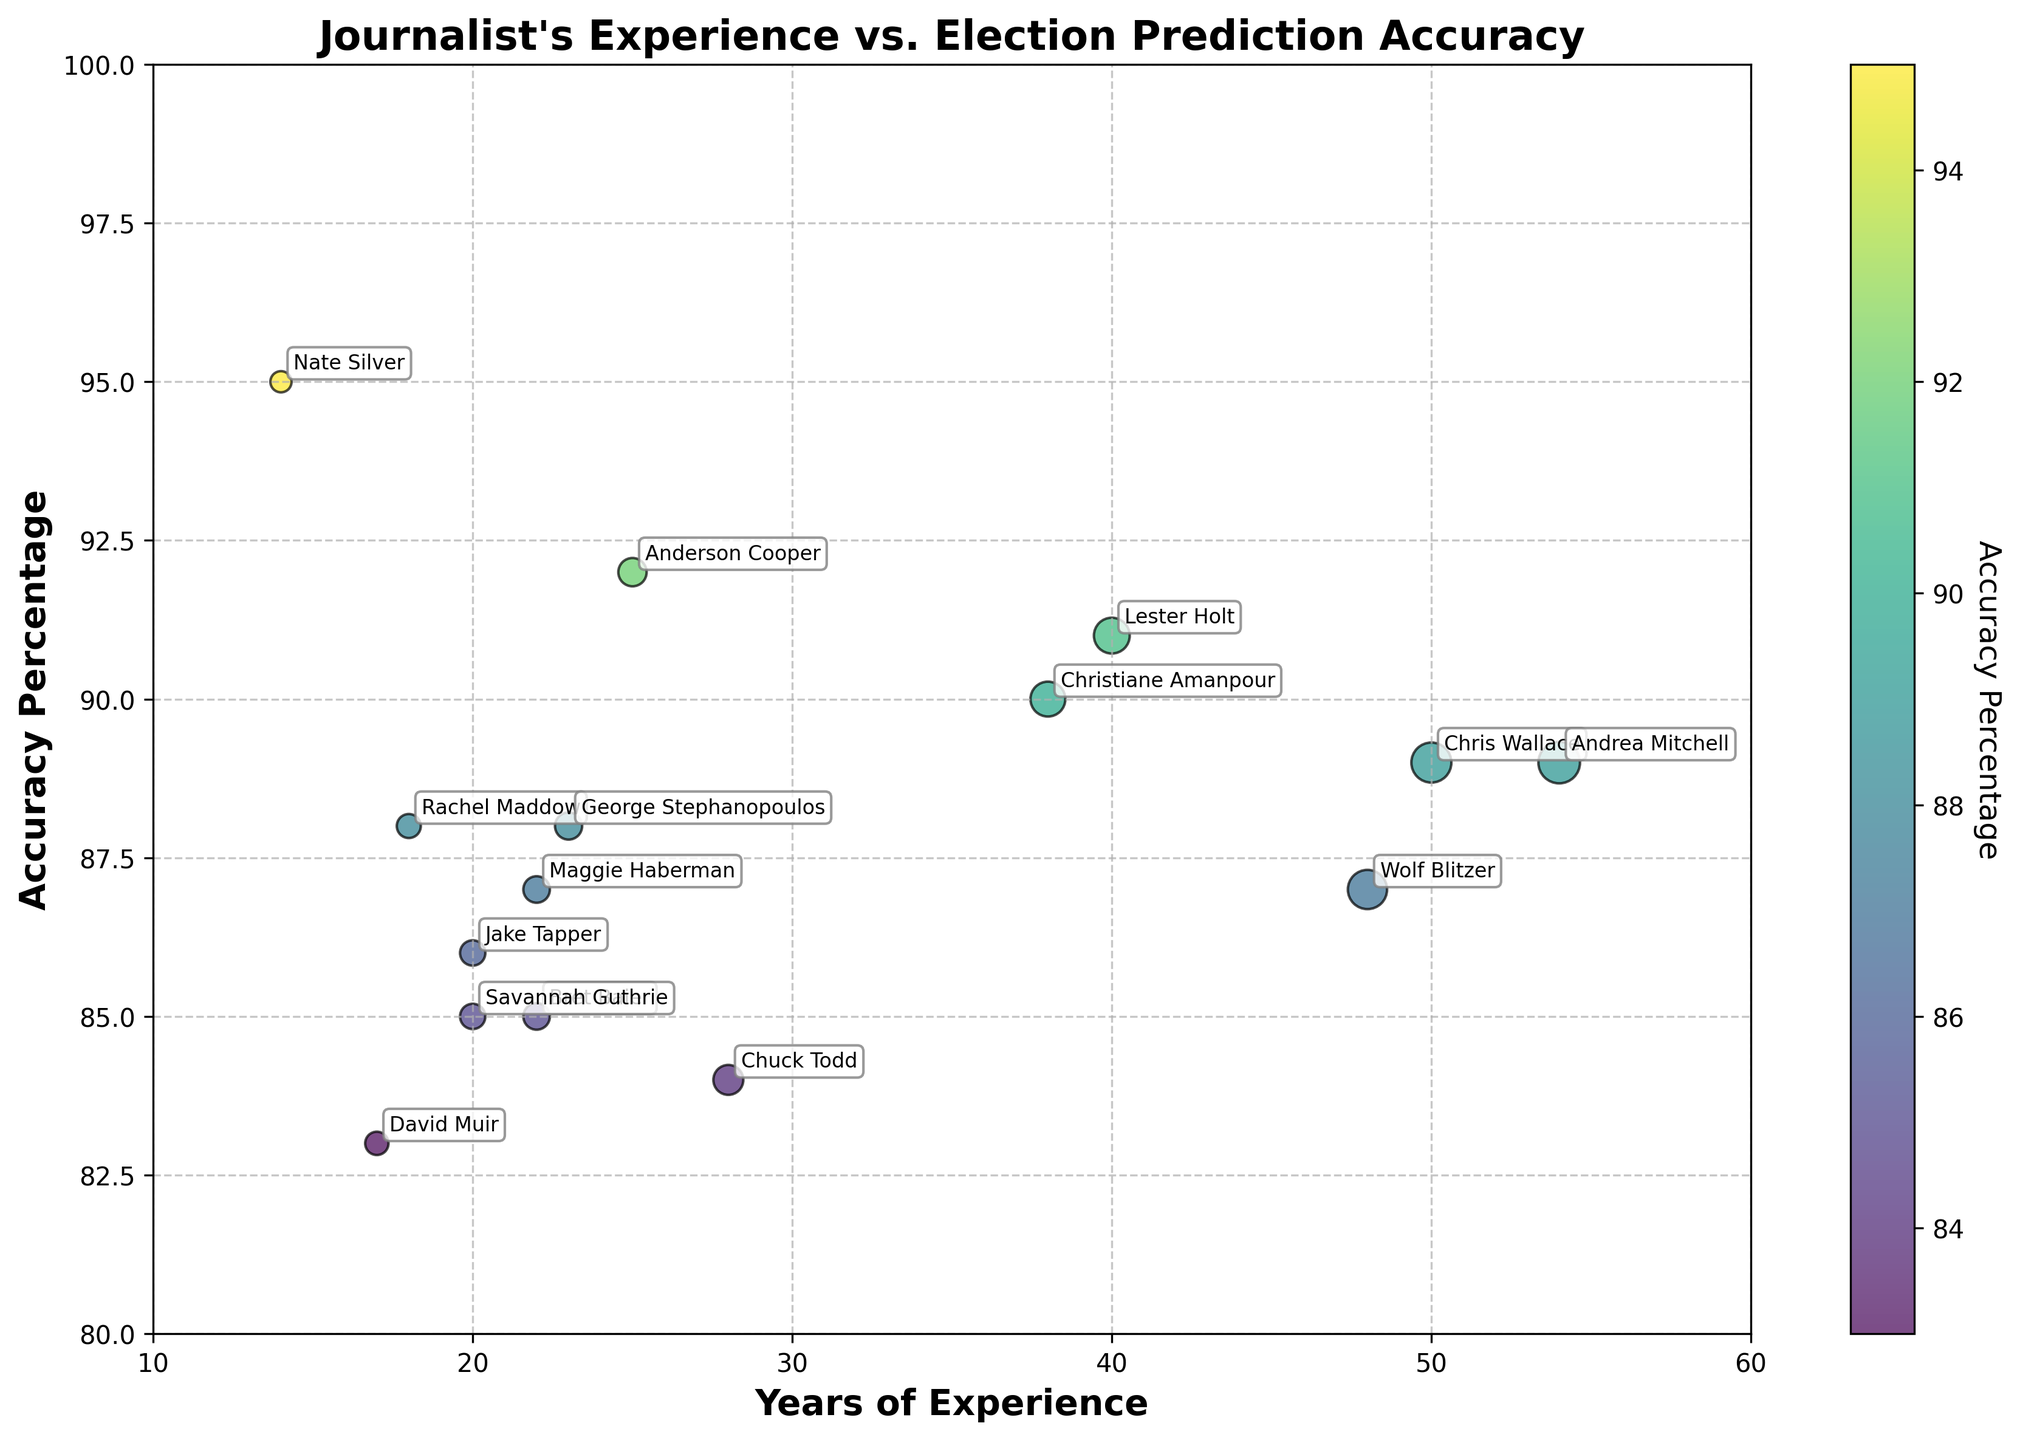How many journalists are represented in the scatter plot? To determine the number of journalists, count the distinct data points in the scatter plot. Each data point represents a different journalist.
Answer: 15 What is the title of the scatter plot? Look at the top of the figure, where the title is usually displayed prominently.
Answer: Journalist's Experience vs. Election Prediction Accuracy Which journalist has the highest accuracy percentage? Identify the data point that reaches the highest on the y-axis (Accuracy Percentage) and check the label associated with it.
Answer: Nate Silver What are the x and y-axis labels in the plot? To find out the labels, look at the text along the horizontal and vertical edges of the plot.
Answer: Years of Experience and Accuracy Percentage Is there a trend between years of experience and accuracy percentage? To observe any trend, look for a pattern in how the data points are distributed along the x and y axes. A general upward or downward trend can indicate a correlation.
Answer: There is no clear trend What is the accuracy percentage of Anderson Cooper? Locate Anderson Cooper's data point on the scatter plot and note its position on the y-axis.
Answer: 92% Compare the accuracy percentages of Chris Wallace and Rachel Maddow. Identify the data points for Chris Wallace and Rachel Maddow, then compare their positions along the y-axis.
Answer: Chris Wallace: 89%; Rachel Maddow: 88% How does the experience of Lester Holt compare with Anderson Cooper? Locate the data points for Lester Holt and Anderson Cooper on the x-axis (Years of Experience) and compare their positions.
Answer: Lester Holt: 40 years; Anderson Cooper: 25 years What is the range of years of experience in the scatter plot? Find the minimum and maximum values on the x-axis (Years of Experience) among all data points.
Answer: 14 to 54 years Is there a color gradient in the scatter plot? If so, what does it represent? Identify whether the data points vary in color and refer to the color bar/legend to understand its representation.
Answer: Yes, it represents Accuracy Percentage 